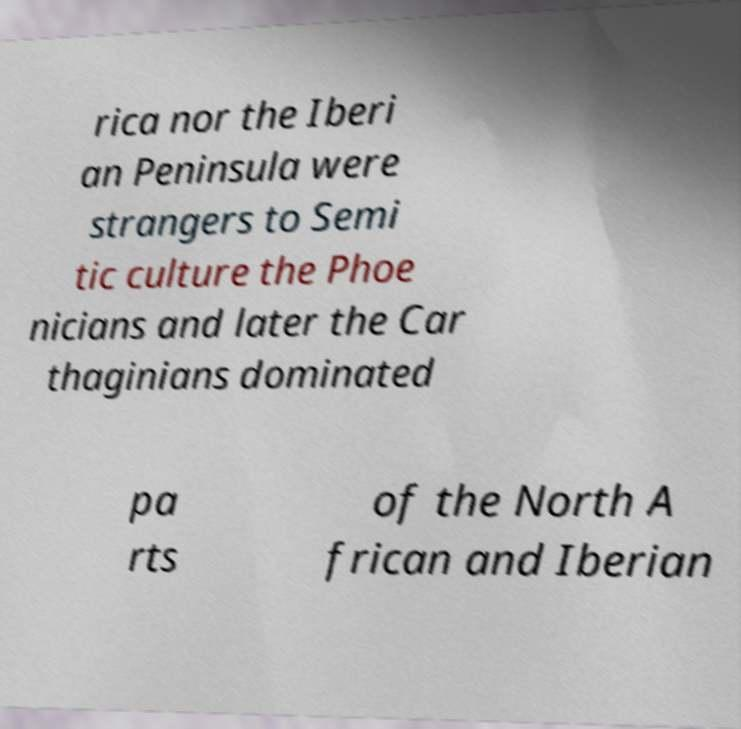Could you assist in decoding the text presented in this image and type it out clearly? rica nor the Iberi an Peninsula were strangers to Semi tic culture the Phoe nicians and later the Car thaginians dominated pa rts of the North A frican and Iberian 